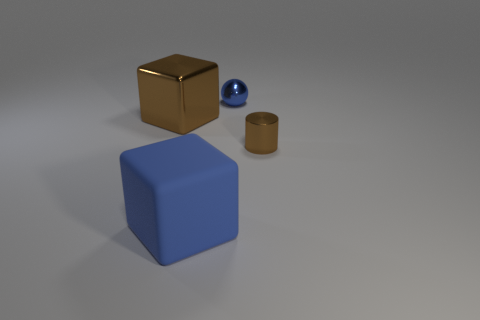How many large things are either brown blocks or blue blocks? 2 